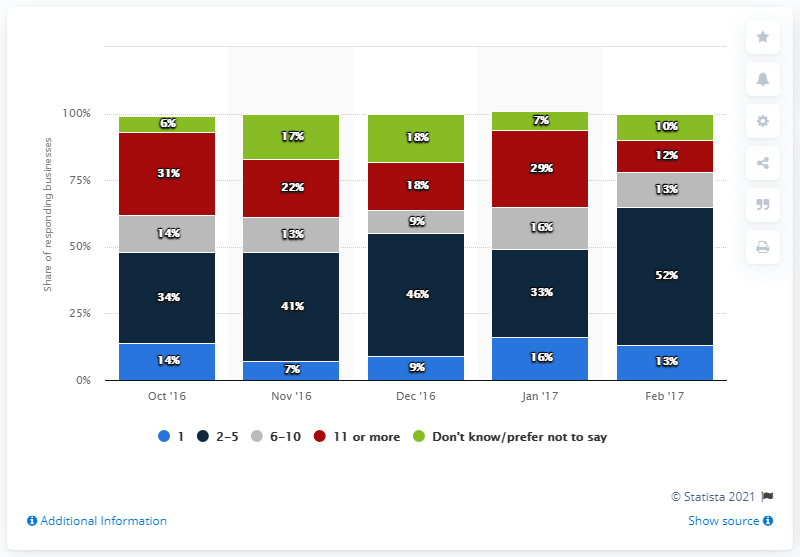Point out several critical features in this image. The light blue color indicates one. The sum of the values between 50 and 60 in the chart is 12. 